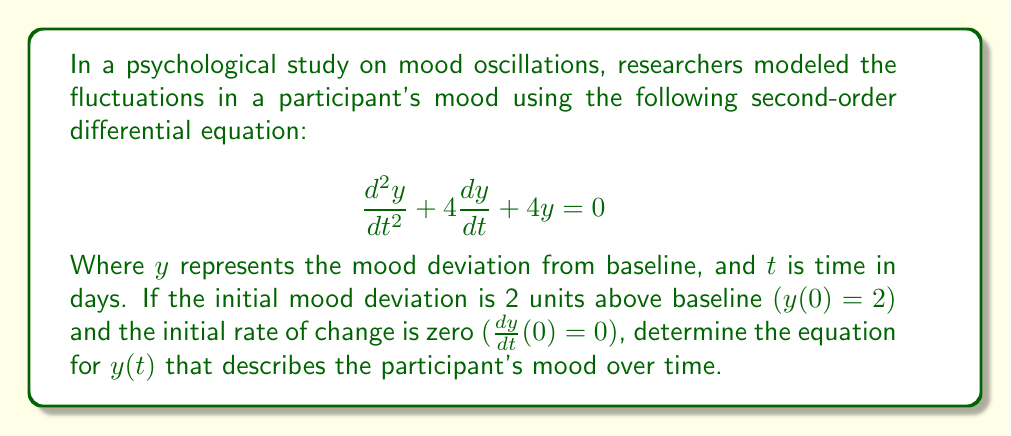Provide a solution to this math problem. To solve this second-order differential equation, we'll follow these steps:

1) First, we recognize this as a homogeneous linear differential equation with constant coefficients. The characteristic equation is:

   $$r^2 + 4r + 4 = 0$$

2) Solving this quadratic equation:
   $$(r + 2)^2 = 0$$
   $$r = -2$$ (repeated root)

3) For a repeated root, the general solution has the form:
   $$y(t) = (c_1 + c_2t)e^{-2t}$$

4) Now we use the initial conditions to find $c_1$ and $c_2$:

   For $y(0) = 2$:
   $$2 = c_1 + 0 \cdot c_2$$
   $$c_1 = 2$$

   For $\frac{dy}{dt}(0) = 0$:
   $$\frac{dy}{dt} = (-2c_1 - 2c_2t + c_2)e^{-2t}$$
   $$0 = -2c_1 + c_2$$
   $$0 = -2(2) + c_2$$
   $$c_2 = 4$$

5) Substituting these values back into the general solution:

   $$y(t) = (2 + 4t)e^{-2t}$$

This equation describes the participant's mood deviation from baseline over time.
Answer: $y(t) = (2 + 4t)e^{-2t}$ 